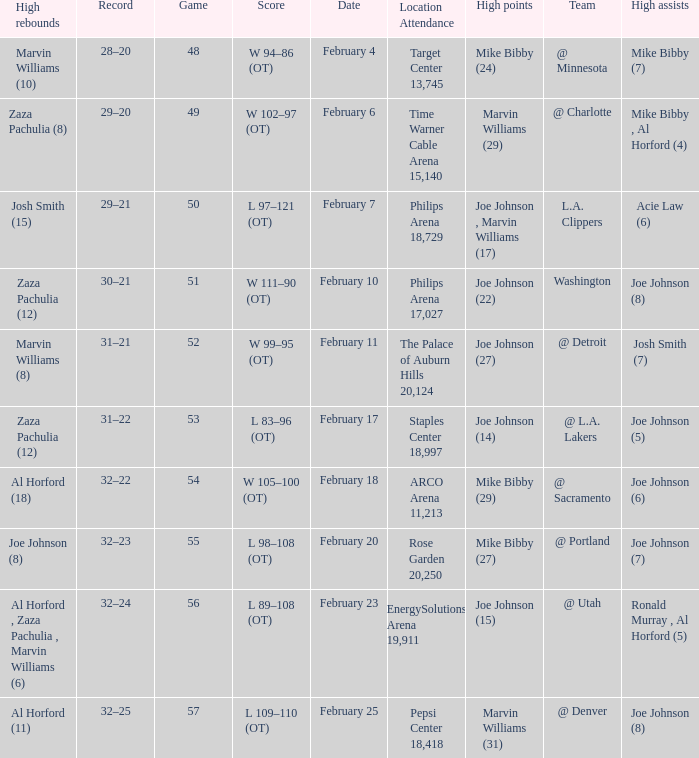How many high assists stats were maade on february 4 1.0. 